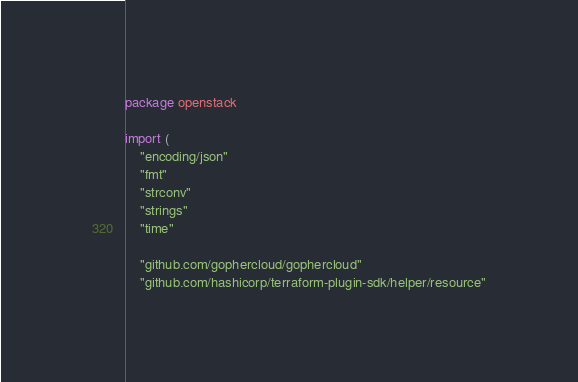<code> <loc_0><loc_0><loc_500><loc_500><_Go_>package openstack

import (
	"encoding/json"
	"fmt"
	"strconv"
	"strings"
	"time"

	"github.com/gophercloud/gophercloud"
	"github.com/hashicorp/terraform-plugin-sdk/helper/resource"</code> 